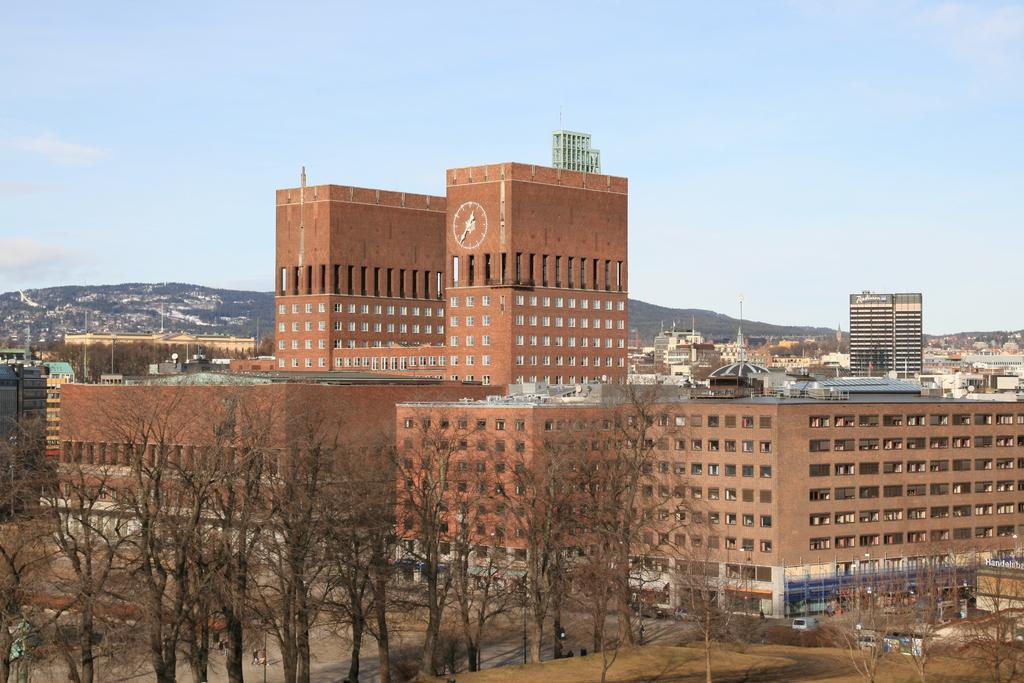In one or two sentences, can you explain what this image depicts? In this picture I can see so many buildings, trees, vehicles on the road and some hills. 